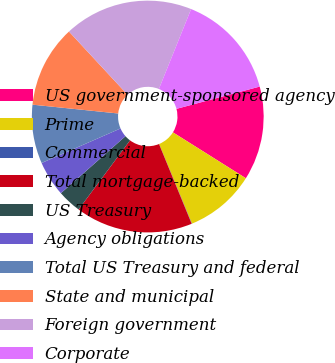Convert chart. <chart><loc_0><loc_0><loc_500><loc_500><pie_chart><fcel>US government-sponsored agency<fcel>Prime<fcel>Commercial<fcel>Total mortgage-backed<fcel>US Treasury<fcel>Agency obligations<fcel>Total US Treasury and federal<fcel>State and municipal<fcel>Foreign government<fcel>Corporate<nl><fcel>13.1%<fcel>9.84%<fcel>0.04%<fcel>16.37%<fcel>3.31%<fcel>4.94%<fcel>8.2%<fcel>11.47%<fcel>18.0%<fcel>14.74%<nl></chart> 